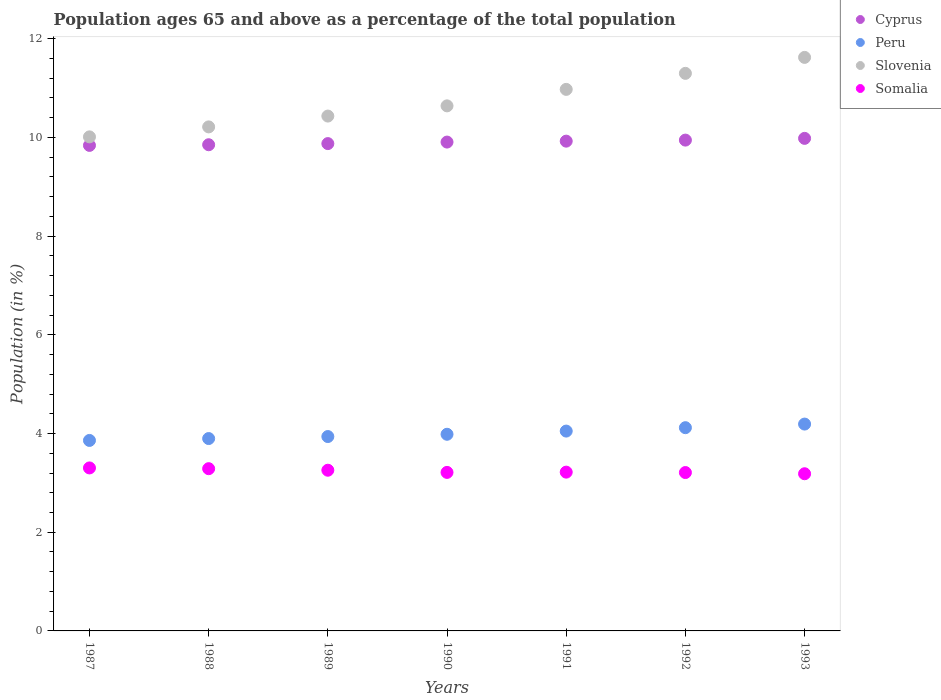Is the number of dotlines equal to the number of legend labels?
Your response must be concise. Yes. What is the percentage of the population ages 65 and above in Peru in 1989?
Keep it short and to the point. 3.94. Across all years, what is the maximum percentage of the population ages 65 and above in Cyprus?
Provide a short and direct response. 9.98. Across all years, what is the minimum percentage of the population ages 65 and above in Cyprus?
Provide a short and direct response. 9.84. In which year was the percentage of the population ages 65 and above in Somalia minimum?
Offer a very short reply. 1993. What is the total percentage of the population ages 65 and above in Cyprus in the graph?
Provide a short and direct response. 69.33. What is the difference between the percentage of the population ages 65 and above in Slovenia in 1989 and that in 1991?
Offer a very short reply. -0.54. What is the difference between the percentage of the population ages 65 and above in Cyprus in 1992 and the percentage of the population ages 65 and above in Somalia in 1989?
Your response must be concise. 6.69. What is the average percentage of the population ages 65 and above in Cyprus per year?
Keep it short and to the point. 9.9. In the year 1990, what is the difference between the percentage of the population ages 65 and above in Peru and percentage of the population ages 65 and above in Cyprus?
Your answer should be compact. -5.92. In how many years, is the percentage of the population ages 65 and above in Slovenia greater than 9.6?
Your answer should be very brief. 7. What is the ratio of the percentage of the population ages 65 and above in Slovenia in 1987 to that in 1988?
Make the answer very short. 0.98. Is the percentage of the population ages 65 and above in Somalia in 1989 less than that in 1993?
Provide a succinct answer. No. What is the difference between the highest and the second highest percentage of the population ages 65 and above in Slovenia?
Your answer should be very brief. 0.32. What is the difference between the highest and the lowest percentage of the population ages 65 and above in Somalia?
Offer a very short reply. 0.12. Is the sum of the percentage of the population ages 65 and above in Slovenia in 1990 and 1991 greater than the maximum percentage of the population ages 65 and above in Cyprus across all years?
Keep it short and to the point. Yes. Is it the case that in every year, the sum of the percentage of the population ages 65 and above in Cyprus and percentage of the population ages 65 and above in Somalia  is greater than the sum of percentage of the population ages 65 and above in Peru and percentage of the population ages 65 and above in Slovenia?
Ensure brevity in your answer.  No. Does the percentage of the population ages 65 and above in Somalia monotonically increase over the years?
Keep it short and to the point. No. Is the percentage of the population ages 65 and above in Cyprus strictly greater than the percentage of the population ages 65 and above in Slovenia over the years?
Provide a succinct answer. No. Is the percentage of the population ages 65 and above in Cyprus strictly less than the percentage of the population ages 65 and above in Slovenia over the years?
Offer a terse response. Yes. How many dotlines are there?
Provide a short and direct response. 4. How many years are there in the graph?
Provide a short and direct response. 7. Are the values on the major ticks of Y-axis written in scientific E-notation?
Offer a terse response. No. How many legend labels are there?
Offer a very short reply. 4. How are the legend labels stacked?
Give a very brief answer. Vertical. What is the title of the graph?
Make the answer very short. Population ages 65 and above as a percentage of the total population. Does "Malawi" appear as one of the legend labels in the graph?
Keep it short and to the point. No. What is the label or title of the Y-axis?
Offer a terse response. Population (in %). What is the Population (in %) in Cyprus in 1987?
Give a very brief answer. 9.84. What is the Population (in %) in Peru in 1987?
Provide a succinct answer. 3.86. What is the Population (in %) in Slovenia in 1987?
Offer a very short reply. 10.01. What is the Population (in %) in Somalia in 1987?
Offer a very short reply. 3.3. What is the Population (in %) of Cyprus in 1988?
Offer a very short reply. 9.85. What is the Population (in %) of Peru in 1988?
Ensure brevity in your answer.  3.9. What is the Population (in %) of Slovenia in 1988?
Provide a short and direct response. 10.21. What is the Population (in %) in Somalia in 1988?
Offer a terse response. 3.29. What is the Population (in %) in Cyprus in 1989?
Your response must be concise. 9.88. What is the Population (in %) of Peru in 1989?
Ensure brevity in your answer.  3.94. What is the Population (in %) in Slovenia in 1989?
Offer a terse response. 10.43. What is the Population (in %) in Somalia in 1989?
Provide a succinct answer. 3.26. What is the Population (in %) in Cyprus in 1990?
Give a very brief answer. 9.91. What is the Population (in %) in Peru in 1990?
Offer a very short reply. 3.99. What is the Population (in %) in Slovenia in 1990?
Your answer should be very brief. 10.64. What is the Population (in %) in Somalia in 1990?
Keep it short and to the point. 3.21. What is the Population (in %) in Cyprus in 1991?
Your answer should be very brief. 9.93. What is the Population (in %) of Peru in 1991?
Provide a succinct answer. 4.05. What is the Population (in %) in Slovenia in 1991?
Make the answer very short. 10.97. What is the Population (in %) of Somalia in 1991?
Give a very brief answer. 3.22. What is the Population (in %) of Cyprus in 1992?
Your answer should be very brief. 9.95. What is the Population (in %) of Peru in 1992?
Offer a terse response. 4.12. What is the Population (in %) in Slovenia in 1992?
Your answer should be compact. 11.3. What is the Population (in %) of Somalia in 1992?
Your response must be concise. 3.21. What is the Population (in %) in Cyprus in 1993?
Your answer should be compact. 9.98. What is the Population (in %) of Peru in 1993?
Ensure brevity in your answer.  4.19. What is the Population (in %) of Slovenia in 1993?
Your response must be concise. 11.62. What is the Population (in %) of Somalia in 1993?
Make the answer very short. 3.19. Across all years, what is the maximum Population (in %) in Cyprus?
Offer a terse response. 9.98. Across all years, what is the maximum Population (in %) of Peru?
Ensure brevity in your answer.  4.19. Across all years, what is the maximum Population (in %) in Slovenia?
Your response must be concise. 11.62. Across all years, what is the maximum Population (in %) of Somalia?
Give a very brief answer. 3.3. Across all years, what is the minimum Population (in %) of Cyprus?
Provide a succinct answer. 9.84. Across all years, what is the minimum Population (in %) in Peru?
Offer a very short reply. 3.86. Across all years, what is the minimum Population (in %) in Slovenia?
Offer a terse response. 10.01. Across all years, what is the minimum Population (in %) in Somalia?
Provide a short and direct response. 3.19. What is the total Population (in %) in Cyprus in the graph?
Provide a short and direct response. 69.33. What is the total Population (in %) of Peru in the graph?
Ensure brevity in your answer.  28.04. What is the total Population (in %) in Slovenia in the graph?
Make the answer very short. 75.2. What is the total Population (in %) of Somalia in the graph?
Provide a short and direct response. 22.67. What is the difference between the Population (in %) in Cyprus in 1987 and that in 1988?
Your answer should be compact. -0.01. What is the difference between the Population (in %) in Peru in 1987 and that in 1988?
Provide a short and direct response. -0.04. What is the difference between the Population (in %) of Slovenia in 1987 and that in 1988?
Give a very brief answer. -0.2. What is the difference between the Population (in %) of Somalia in 1987 and that in 1988?
Your answer should be compact. 0.02. What is the difference between the Population (in %) in Cyprus in 1987 and that in 1989?
Your answer should be compact. -0.04. What is the difference between the Population (in %) of Peru in 1987 and that in 1989?
Offer a terse response. -0.08. What is the difference between the Population (in %) in Slovenia in 1987 and that in 1989?
Give a very brief answer. -0.42. What is the difference between the Population (in %) of Somalia in 1987 and that in 1989?
Provide a succinct answer. 0.05. What is the difference between the Population (in %) of Cyprus in 1987 and that in 1990?
Ensure brevity in your answer.  -0.07. What is the difference between the Population (in %) of Peru in 1987 and that in 1990?
Give a very brief answer. -0.12. What is the difference between the Population (in %) in Slovenia in 1987 and that in 1990?
Offer a terse response. -0.63. What is the difference between the Population (in %) of Somalia in 1987 and that in 1990?
Make the answer very short. 0.09. What is the difference between the Population (in %) in Cyprus in 1987 and that in 1991?
Your answer should be very brief. -0.09. What is the difference between the Population (in %) in Peru in 1987 and that in 1991?
Keep it short and to the point. -0.19. What is the difference between the Population (in %) in Slovenia in 1987 and that in 1991?
Ensure brevity in your answer.  -0.96. What is the difference between the Population (in %) of Somalia in 1987 and that in 1991?
Offer a very short reply. 0.09. What is the difference between the Population (in %) in Cyprus in 1987 and that in 1992?
Ensure brevity in your answer.  -0.11. What is the difference between the Population (in %) in Peru in 1987 and that in 1992?
Offer a terse response. -0.26. What is the difference between the Population (in %) of Slovenia in 1987 and that in 1992?
Ensure brevity in your answer.  -1.29. What is the difference between the Population (in %) in Somalia in 1987 and that in 1992?
Keep it short and to the point. 0.09. What is the difference between the Population (in %) in Cyprus in 1987 and that in 1993?
Ensure brevity in your answer.  -0.14. What is the difference between the Population (in %) in Peru in 1987 and that in 1993?
Give a very brief answer. -0.33. What is the difference between the Population (in %) of Slovenia in 1987 and that in 1993?
Give a very brief answer. -1.61. What is the difference between the Population (in %) in Somalia in 1987 and that in 1993?
Your answer should be compact. 0.12. What is the difference between the Population (in %) in Cyprus in 1988 and that in 1989?
Provide a succinct answer. -0.02. What is the difference between the Population (in %) of Peru in 1988 and that in 1989?
Make the answer very short. -0.04. What is the difference between the Population (in %) in Slovenia in 1988 and that in 1989?
Offer a terse response. -0.22. What is the difference between the Population (in %) in Somalia in 1988 and that in 1989?
Your answer should be very brief. 0.03. What is the difference between the Population (in %) of Cyprus in 1988 and that in 1990?
Keep it short and to the point. -0.05. What is the difference between the Population (in %) in Peru in 1988 and that in 1990?
Make the answer very short. -0.09. What is the difference between the Population (in %) of Slovenia in 1988 and that in 1990?
Keep it short and to the point. -0.43. What is the difference between the Population (in %) of Somalia in 1988 and that in 1990?
Offer a terse response. 0.08. What is the difference between the Population (in %) in Cyprus in 1988 and that in 1991?
Your answer should be compact. -0.07. What is the difference between the Population (in %) of Peru in 1988 and that in 1991?
Provide a short and direct response. -0.15. What is the difference between the Population (in %) of Slovenia in 1988 and that in 1991?
Make the answer very short. -0.76. What is the difference between the Population (in %) of Somalia in 1988 and that in 1991?
Keep it short and to the point. 0.07. What is the difference between the Population (in %) of Cyprus in 1988 and that in 1992?
Keep it short and to the point. -0.09. What is the difference between the Population (in %) of Peru in 1988 and that in 1992?
Your answer should be compact. -0.22. What is the difference between the Population (in %) of Slovenia in 1988 and that in 1992?
Keep it short and to the point. -1.09. What is the difference between the Population (in %) of Somalia in 1988 and that in 1992?
Your answer should be compact. 0.08. What is the difference between the Population (in %) in Cyprus in 1988 and that in 1993?
Your response must be concise. -0.13. What is the difference between the Population (in %) of Peru in 1988 and that in 1993?
Give a very brief answer. -0.29. What is the difference between the Population (in %) of Slovenia in 1988 and that in 1993?
Provide a short and direct response. -1.41. What is the difference between the Population (in %) in Somalia in 1988 and that in 1993?
Your answer should be very brief. 0.1. What is the difference between the Population (in %) of Cyprus in 1989 and that in 1990?
Keep it short and to the point. -0.03. What is the difference between the Population (in %) of Peru in 1989 and that in 1990?
Your response must be concise. -0.05. What is the difference between the Population (in %) of Slovenia in 1989 and that in 1990?
Ensure brevity in your answer.  -0.21. What is the difference between the Population (in %) in Somalia in 1989 and that in 1990?
Provide a succinct answer. 0.04. What is the difference between the Population (in %) in Cyprus in 1989 and that in 1991?
Give a very brief answer. -0.05. What is the difference between the Population (in %) of Peru in 1989 and that in 1991?
Make the answer very short. -0.11. What is the difference between the Population (in %) of Slovenia in 1989 and that in 1991?
Make the answer very short. -0.54. What is the difference between the Population (in %) in Somalia in 1989 and that in 1991?
Your response must be concise. 0.04. What is the difference between the Population (in %) of Cyprus in 1989 and that in 1992?
Provide a short and direct response. -0.07. What is the difference between the Population (in %) of Peru in 1989 and that in 1992?
Keep it short and to the point. -0.18. What is the difference between the Population (in %) of Slovenia in 1989 and that in 1992?
Keep it short and to the point. -0.87. What is the difference between the Population (in %) in Somalia in 1989 and that in 1992?
Your response must be concise. 0.05. What is the difference between the Population (in %) of Cyprus in 1989 and that in 1993?
Keep it short and to the point. -0.11. What is the difference between the Population (in %) of Peru in 1989 and that in 1993?
Your response must be concise. -0.25. What is the difference between the Population (in %) of Slovenia in 1989 and that in 1993?
Ensure brevity in your answer.  -1.19. What is the difference between the Population (in %) of Somalia in 1989 and that in 1993?
Provide a short and direct response. 0.07. What is the difference between the Population (in %) of Cyprus in 1990 and that in 1991?
Offer a very short reply. -0.02. What is the difference between the Population (in %) of Peru in 1990 and that in 1991?
Provide a succinct answer. -0.06. What is the difference between the Population (in %) in Slovenia in 1990 and that in 1991?
Your answer should be compact. -0.33. What is the difference between the Population (in %) in Somalia in 1990 and that in 1991?
Provide a short and direct response. -0.01. What is the difference between the Population (in %) in Cyprus in 1990 and that in 1992?
Your answer should be very brief. -0.04. What is the difference between the Population (in %) of Peru in 1990 and that in 1992?
Offer a very short reply. -0.13. What is the difference between the Population (in %) in Slovenia in 1990 and that in 1992?
Give a very brief answer. -0.66. What is the difference between the Population (in %) in Somalia in 1990 and that in 1992?
Keep it short and to the point. 0. What is the difference between the Population (in %) of Cyprus in 1990 and that in 1993?
Offer a terse response. -0.08. What is the difference between the Population (in %) in Peru in 1990 and that in 1993?
Provide a short and direct response. -0.21. What is the difference between the Population (in %) in Slovenia in 1990 and that in 1993?
Offer a very short reply. -0.98. What is the difference between the Population (in %) in Somalia in 1990 and that in 1993?
Provide a succinct answer. 0.03. What is the difference between the Population (in %) in Cyprus in 1991 and that in 1992?
Your answer should be compact. -0.02. What is the difference between the Population (in %) in Peru in 1991 and that in 1992?
Give a very brief answer. -0.07. What is the difference between the Population (in %) of Slovenia in 1991 and that in 1992?
Offer a very short reply. -0.32. What is the difference between the Population (in %) of Somalia in 1991 and that in 1992?
Make the answer very short. 0.01. What is the difference between the Population (in %) of Cyprus in 1991 and that in 1993?
Your response must be concise. -0.06. What is the difference between the Population (in %) in Peru in 1991 and that in 1993?
Your answer should be very brief. -0.14. What is the difference between the Population (in %) in Slovenia in 1991 and that in 1993?
Provide a succinct answer. -0.65. What is the difference between the Population (in %) in Somalia in 1991 and that in 1993?
Ensure brevity in your answer.  0.03. What is the difference between the Population (in %) in Cyprus in 1992 and that in 1993?
Offer a very short reply. -0.04. What is the difference between the Population (in %) in Peru in 1992 and that in 1993?
Give a very brief answer. -0.07. What is the difference between the Population (in %) in Slovenia in 1992 and that in 1993?
Your answer should be very brief. -0.32. What is the difference between the Population (in %) of Somalia in 1992 and that in 1993?
Ensure brevity in your answer.  0.02. What is the difference between the Population (in %) in Cyprus in 1987 and the Population (in %) in Peru in 1988?
Provide a short and direct response. 5.94. What is the difference between the Population (in %) of Cyprus in 1987 and the Population (in %) of Slovenia in 1988?
Keep it short and to the point. -0.37. What is the difference between the Population (in %) in Cyprus in 1987 and the Population (in %) in Somalia in 1988?
Your answer should be very brief. 6.55. What is the difference between the Population (in %) of Peru in 1987 and the Population (in %) of Slovenia in 1988?
Offer a terse response. -6.35. What is the difference between the Population (in %) in Peru in 1987 and the Population (in %) in Somalia in 1988?
Provide a succinct answer. 0.57. What is the difference between the Population (in %) of Slovenia in 1987 and the Population (in %) of Somalia in 1988?
Ensure brevity in your answer.  6.72. What is the difference between the Population (in %) of Cyprus in 1987 and the Population (in %) of Peru in 1989?
Your response must be concise. 5.9. What is the difference between the Population (in %) in Cyprus in 1987 and the Population (in %) in Slovenia in 1989?
Offer a terse response. -0.59. What is the difference between the Population (in %) of Cyprus in 1987 and the Population (in %) of Somalia in 1989?
Provide a short and direct response. 6.58. What is the difference between the Population (in %) in Peru in 1987 and the Population (in %) in Slovenia in 1989?
Your answer should be very brief. -6.57. What is the difference between the Population (in %) of Peru in 1987 and the Population (in %) of Somalia in 1989?
Offer a terse response. 0.6. What is the difference between the Population (in %) in Slovenia in 1987 and the Population (in %) in Somalia in 1989?
Ensure brevity in your answer.  6.76. What is the difference between the Population (in %) of Cyprus in 1987 and the Population (in %) of Peru in 1990?
Provide a succinct answer. 5.85. What is the difference between the Population (in %) in Cyprus in 1987 and the Population (in %) in Slovenia in 1990?
Your answer should be compact. -0.8. What is the difference between the Population (in %) in Cyprus in 1987 and the Population (in %) in Somalia in 1990?
Your response must be concise. 6.63. What is the difference between the Population (in %) of Peru in 1987 and the Population (in %) of Slovenia in 1990?
Your answer should be compact. -6.78. What is the difference between the Population (in %) in Peru in 1987 and the Population (in %) in Somalia in 1990?
Ensure brevity in your answer.  0.65. What is the difference between the Population (in %) in Slovenia in 1987 and the Population (in %) in Somalia in 1990?
Ensure brevity in your answer.  6.8. What is the difference between the Population (in %) in Cyprus in 1987 and the Population (in %) in Peru in 1991?
Offer a terse response. 5.79. What is the difference between the Population (in %) in Cyprus in 1987 and the Population (in %) in Slovenia in 1991?
Ensure brevity in your answer.  -1.14. What is the difference between the Population (in %) in Cyprus in 1987 and the Population (in %) in Somalia in 1991?
Ensure brevity in your answer.  6.62. What is the difference between the Population (in %) in Peru in 1987 and the Population (in %) in Slovenia in 1991?
Give a very brief answer. -7.11. What is the difference between the Population (in %) of Peru in 1987 and the Population (in %) of Somalia in 1991?
Your response must be concise. 0.64. What is the difference between the Population (in %) of Slovenia in 1987 and the Population (in %) of Somalia in 1991?
Your response must be concise. 6.79. What is the difference between the Population (in %) in Cyprus in 1987 and the Population (in %) in Peru in 1992?
Ensure brevity in your answer.  5.72. What is the difference between the Population (in %) of Cyprus in 1987 and the Population (in %) of Slovenia in 1992?
Offer a very short reply. -1.46. What is the difference between the Population (in %) in Cyprus in 1987 and the Population (in %) in Somalia in 1992?
Keep it short and to the point. 6.63. What is the difference between the Population (in %) of Peru in 1987 and the Population (in %) of Slovenia in 1992?
Provide a succinct answer. -7.44. What is the difference between the Population (in %) in Peru in 1987 and the Population (in %) in Somalia in 1992?
Provide a succinct answer. 0.65. What is the difference between the Population (in %) of Slovenia in 1987 and the Population (in %) of Somalia in 1992?
Offer a terse response. 6.8. What is the difference between the Population (in %) of Cyprus in 1987 and the Population (in %) of Peru in 1993?
Ensure brevity in your answer.  5.65. What is the difference between the Population (in %) of Cyprus in 1987 and the Population (in %) of Slovenia in 1993?
Provide a short and direct response. -1.78. What is the difference between the Population (in %) of Cyprus in 1987 and the Population (in %) of Somalia in 1993?
Give a very brief answer. 6.65. What is the difference between the Population (in %) in Peru in 1987 and the Population (in %) in Slovenia in 1993?
Your answer should be compact. -7.76. What is the difference between the Population (in %) of Peru in 1987 and the Population (in %) of Somalia in 1993?
Give a very brief answer. 0.68. What is the difference between the Population (in %) in Slovenia in 1987 and the Population (in %) in Somalia in 1993?
Make the answer very short. 6.83. What is the difference between the Population (in %) in Cyprus in 1988 and the Population (in %) in Peru in 1989?
Keep it short and to the point. 5.91. What is the difference between the Population (in %) in Cyprus in 1988 and the Population (in %) in Slovenia in 1989?
Provide a short and direct response. -0.58. What is the difference between the Population (in %) of Cyprus in 1988 and the Population (in %) of Somalia in 1989?
Your answer should be compact. 6.6. What is the difference between the Population (in %) in Peru in 1988 and the Population (in %) in Slovenia in 1989?
Offer a very short reply. -6.54. What is the difference between the Population (in %) in Peru in 1988 and the Population (in %) in Somalia in 1989?
Give a very brief answer. 0.64. What is the difference between the Population (in %) of Slovenia in 1988 and the Population (in %) of Somalia in 1989?
Your answer should be compact. 6.96. What is the difference between the Population (in %) of Cyprus in 1988 and the Population (in %) of Peru in 1990?
Keep it short and to the point. 5.87. What is the difference between the Population (in %) in Cyprus in 1988 and the Population (in %) in Slovenia in 1990?
Provide a succinct answer. -0.79. What is the difference between the Population (in %) of Cyprus in 1988 and the Population (in %) of Somalia in 1990?
Ensure brevity in your answer.  6.64. What is the difference between the Population (in %) of Peru in 1988 and the Population (in %) of Slovenia in 1990?
Keep it short and to the point. -6.74. What is the difference between the Population (in %) in Peru in 1988 and the Population (in %) in Somalia in 1990?
Keep it short and to the point. 0.69. What is the difference between the Population (in %) in Slovenia in 1988 and the Population (in %) in Somalia in 1990?
Offer a terse response. 7. What is the difference between the Population (in %) in Cyprus in 1988 and the Population (in %) in Peru in 1991?
Provide a succinct answer. 5.8. What is the difference between the Population (in %) in Cyprus in 1988 and the Population (in %) in Slovenia in 1991?
Keep it short and to the point. -1.12. What is the difference between the Population (in %) in Cyprus in 1988 and the Population (in %) in Somalia in 1991?
Offer a terse response. 6.63. What is the difference between the Population (in %) in Peru in 1988 and the Population (in %) in Slovenia in 1991?
Provide a short and direct response. -7.08. What is the difference between the Population (in %) of Peru in 1988 and the Population (in %) of Somalia in 1991?
Make the answer very short. 0.68. What is the difference between the Population (in %) in Slovenia in 1988 and the Population (in %) in Somalia in 1991?
Offer a very short reply. 7. What is the difference between the Population (in %) of Cyprus in 1988 and the Population (in %) of Peru in 1992?
Ensure brevity in your answer.  5.73. What is the difference between the Population (in %) in Cyprus in 1988 and the Population (in %) in Slovenia in 1992?
Provide a short and direct response. -1.45. What is the difference between the Population (in %) in Cyprus in 1988 and the Population (in %) in Somalia in 1992?
Ensure brevity in your answer.  6.64. What is the difference between the Population (in %) in Peru in 1988 and the Population (in %) in Slovenia in 1992?
Your answer should be very brief. -7.4. What is the difference between the Population (in %) in Peru in 1988 and the Population (in %) in Somalia in 1992?
Offer a very short reply. 0.69. What is the difference between the Population (in %) of Slovenia in 1988 and the Population (in %) of Somalia in 1992?
Keep it short and to the point. 7. What is the difference between the Population (in %) of Cyprus in 1988 and the Population (in %) of Peru in 1993?
Make the answer very short. 5.66. What is the difference between the Population (in %) in Cyprus in 1988 and the Population (in %) in Slovenia in 1993?
Your response must be concise. -1.77. What is the difference between the Population (in %) of Cyprus in 1988 and the Population (in %) of Somalia in 1993?
Your answer should be compact. 6.67. What is the difference between the Population (in %) in Peru in 1988 and the Population (in %) in Slovenia in 1993?
Provide a short and direct response. -7.72. What is the difference between the Population (in %) in Peru in 1988 and the Population (in %) in Somalia in 1993?
Offer a very short reply. 0.71. What is the difference between the Population (in %) in Slovenia in 1988 and the Population (in %) in Somalia in 1993?
Your answer should be very brief. 7.03. What is the difference between the Population (in %) of Cyprus in 1989 and the Population (in %) of Peru in 1990?
Keep it short and to the point. 5.89. What is the difference between the Population (in %) in Cyprus in 1989 and the Population (in %) in Slovenia in 1990?
Make the answer very short. -0.76. What is the difference between the Population (in %) in Cyprus in 1989 and the Population (in %) in Somalia in 1990?
Give a very brief answer. 6.66. What is the difference between the Population (in %) of Peru in 1989 and the Population (in %) of Slovenia in 1990?
Keep it short and to the point. -6.7. What is the difference between the Population (in %) in Peru in 1989 and the Population (in %) in Somalia in 1990?
Offer a terse response. 0.73. What is the difference between the Population (in %) of Slovenia in 1989 and the Population (in %) of Somalia in 1990?
Your response must be concise. 7.22. What is the difference between the Population (in %) of Cyprus in 1989 and the Population (in %) of Peru in 1991?
Your answer should be very brief. 5.83. What is the difference between the Population (in %) of Cyprus in 1989 and the Population (in %) of Slovenia in 1991?
Your answer should be very brief. -1.1. What is the difference between the Population (in %) of Cyprus in 1989 and the Population (in %) of Somalia in 1991?
Offer a very short reply. 6.66. What is the difference between the Population (in %) of Peru in 1989 and the Population (in %) of Slovenia in 1991?
Your answer should be compact. -7.04. What is the difference between the Population (in %) of Peru in 1989 and the Population (in %) of Somalia in 1991?
Provide a succinct answer. 0.72. What is the difference between the Population (in %) in Slovenia in 1989 and the Population (in %) in Somalia in 1991?
Your answer should be very brief. 7.22. What is the difference between the Population (in %) of Cyprus in 1989 and the Population (in %) of Peru in 1992?
Your answer should be compact. 5.76. What is the difference between the Population (in %) of Cyprus in 1989 and the Population (in %) of Slovenia in 1992?
Make the answer very short. -1.42. What is the difference between the Population (in %) of Cyprus in 1989 and the Population (in %) of Somalia in 1992?
Your response must be concise. 6.67. What is the difference between the Population (in %) in Peru in 1989 and the Population (in %) in Slovenia in 1992?
Offer a terse response. -7.36. What is the difference between the Population (in %) of Peru in 1989 and the Population (in %) of Somalia in 1992?
Provide a short and direct response. 0.73. What is the difference between the Population (in %) in Slovenia in 1989 and the Population (in %) in Somalia in 1992?
Ensure brevity in your answer.  7.22. What is the difference between the Population (in %) in Cyprus in 1989 and the Population (in %) in Peru in 1993?
Keep it short and to the point. 5.68. What is the difference between the Population (in %) in Cyprus in 1989 and the Population (in %) in Slovenia in 1993?
Provide a short and direct response. -1.75. What is the difference between the Population (in %) in Cyprus in 1989 and the Population (in %) in Somalia in 1993?
Your answer should be very brief. 6.69. What is the difference between the Population (in %) in Peru in 1989 and the Population (in %) in Slovenia in 1993?
Make the answer very short. -7.68. What is the difference between the Population (in %) of Peru in 1989 and the Population (in %) of Somalia in 1993?
Your answer should be compact. 0.75. What is the difference between the Population (in %) of Slovenia in 1989 and the Population (in %) of Somalia in 1993?
Your answer should be very brief. 7.25. What is the difference between the Population (in %) of Cyprus in 1990 and the Population (in %) of Peru in 1991?
Offer a terse response. 5.86. What is the difference between the Population (in %) of Cyprus in 1990 and the Population (in %) of Slovenia in 1991?
Your answer should be very brief. -1.07. What is the difference between the Population (in %) of Cyprus in 1990 and the Population (in %) of Somalia in 1991?
Provide a short and direct response. 6.69. What is the difference between the Population (in %) in Peru in 1990 and the Population (in %) in Slovenia in 1991?
Offer a very short reply. -6.99. What is the difference between the Population (in %) of Peru in 1990 and the Population (in %) of Somalia in 1991?
Provide a short and direct response. 0.77. What is the difference between the Population (in %) of Slovenia in 1990 and the Population (in %) of Somalia in 1991?
Provide a short and direct response. 7.42. What is the difference between the Population (in %) of Cyprus in 1990 and the Population (in %) of Peru in 1992?
Keep it short and to the point. 5.79. What is the difference between the Population (in %) of Cyprus in 1990 and the Population (in %) of Slovenia in 1992?
Your response must be concise. -1.39. What is the difference between the Population (in %) of Cyprus in 1990 and the Population (in %) of Somalia in 1992?
Your answer should be very brief. 6.7. What is the difference between the Population (in %) of Peru in 1990 and the Population (in %) of Slovenia in 1992?
Provide a short and direct response. -7.31. What is the difference between the Population (in %) in Peru in 1990 and the Population (in %) in Somalia in 1992?
Your response must be concise. 0.78. What is the difference between the Population (in %) of Slovenia in 1990 and the Population (in %) of Somalia in 1992?
Offer a terse response. 7.43. What is the difference between the Population (in %) in Cyprus in 1990 and the Population (in %) in Peru in 1993?
Your answer should be compact. 5.71. What is the difference between the Population (in %) of Cyprus in 1990 and the Population (in %) of Slovenia in 1993?
Offer a very short reply. -1.72. What is the difference between the Population (in %) in Cyprus in 1990 and the Population (in %) in Somalia in 1993?
Your response must be concise. 6.72. What is the difference between the Population (in %) of Peru in 1990 and the Population (in %) of Slovenia in 1993?
Your answer should be compact. -7.64. What is the difference between the Population (in %) of Peru in 1990 and the Population (in %) of Somalia in 1993?
Offer a terse response. 0.8. What is the difference between the Population (in %) of Slovenia in 1990 and the Population (in %) of Somalia in 1993?
Your response must be concise. 7.46. What is the difference between the Population (in %) in Cyprus in 1991 and the Population (in %) in Peru in 1992?
Provide a short and direct response. 5.81. What is the difference between the Population (in %) of Cyprus in 1991 and the Population (in %) of Slovenia in 1992?
Provide a succinct answer. -1.37. What is the difference between the Population (in %) in Cyprus in 1991 and the Population (in %) in Somalia in 1992?
Your answer should be very brief. 6.72. What is the difference between the Population (in %) of Peru in 1991 and the Population (in %) of Slovenia in 1992?
Make the answer very short. -7.25. What is the difference between the Population (in %) of Peru in 1991 and the Population (in %) of Somalia in 1992?
Offer a terse response. 0.84. What is the difference between the Population (in %) in Slovenia in 1991 and the Population (in %) in Somalia in 1992?
Offer a very short reply. 7.76. What is the difference between the Population (in %) of Cyprus in 1991 and the Population (in %) of Peru in 1993?
Give a very brief answer. 5.73. What is the difference between the Population (in %) in Cyprus in 1991 and the Population (in %) in Slovenia in 1993?
Keep it short and to the point. -1.7. What is the difference between the Population (in %) of Cyprus in 1991 and the Population (in %) of Somalia in 1993?
Ensure brevity in your answer.  6.74. What is the difference between the Population (in %) in Peru in 1991 and the Population (in %) in Slovenia in 1993?
Your answer should be compact. -7.57. What is the difference between the Population (in %) of Peru in 1991 and the Population (in %) of Somalia in 1993?
Provide a short and direct response. 0.86. What is the difference between the Population (in %) of Slovenia in 1991 and the Population (in %) of Somalia in 1993?
Give a very brief answer. 7.79. What is the difference between the Population (in %) in Cyprus in 1992 and the Population (in %) in Peru in 1993?
Provide a short and direct response. 5.75. What is the difference between the Population (in %) of Cyprus in 1992 and the Population (in %) of Slovenia in 1993?
Provide a short and direct response. -1.68. What is the difference between the Population (in %) of Cyprus in 1992 and the Population (in %) of Somalia in 1993?
Provide a succinct answer. 6.76. What is the difference between the Population (in %) of Peru in 1992 and the Population (in %) of Slovenia in 1993?
Your answer should be very brief. -7.5. What is the difference between the Population (in %) in Peru in 1992 and the Population (in %) in Somalia in 1993?
Provide a short and direct response. 0.93. What is the difference between the Population (in %) of Slovenia in 1992 and the Population (in %) of Somalia in 1993?
Your response must be concise. 8.11. What is the average Population (in %) in Cyprus per year?
Keep it short and to the point. 9.9. What is the average Population (in %) in Peru per year?
Make the answer very short. 4.01. What is the average Population (in %) of Slovenia per year?
Provide a succinct answer. 10.74. What is the average Population (in %) in Somalia per year?
Offer a very short reply. 3.24. In the year 1987, what is the difference between the Population (in %) of Cyprus and Population (in %) of Peru?
Your response must be concise. 5.98. In the year 1987, what is the difference between the Population (in %) in Cyprus and Population (in %) in Slovenia?
Give a very brief answer. -0.17. In the year 1987, what is the difference between the Population (in %) of Cyprus and Population (in %) of Somalia?
Keep it short and to the point. 6.54. In the year 1987, what is the difference between the Population (in %) in Peru and Population (in %) in Slovenia?
Give a very brief answer. -6.15. In the year 1987, what is the difference between the Population (in %) of Peru and Population (in %) of Somalia?
Your response must be concise. 0.56. In the year 1987, what is the difference between the Population (in %) of Slovenia and Population (in %) of Somalia?
Provide a short and direct response. 6.71. In the year 1988, what is the difference between the Population (in %) in Cyprus and Population (in %) in Peru?
Your response must be concise. 5.95. In the year 1988, what is the difference between the Population (in %) in Cyprus and Population (in %) in Slovenia?
Your answer should be compact. -0.36. In the year 1988, what is the difference between the Population (in %) in Cyprus and Population (in %) in Somalia?
Provide a short and direct response. 6.56. In the year 1988, what is the difference between the Population (in %) in Peru and Population (in %) in Slovenia?
Provide a succinct answer. -6.32. In the year 1988, what is the difference between the Population (in %) of Peru and Population (in %) of Somalia?
Offer a very short reply. 0.61. In the year 1988, what is the difference between the Population (in %) in Slovenia and Population (in %) in Somalia?
Your response must be concise. 6.93. In the year 1989, what is the difference between the Population (in %) of Cyprus and Population (in %) of Peru?
Keep it short and to the point. 5.94. In the year 1989, what is the difference between the Population (in %) in Cyprus and Population (in %) in Slovenia?
Offer a very short reply. -0.56. In the year 1989, what is the difference between the Population (in %) in Cyprus and Population (in %) in Somalia?
Offer a terse response. 6.62. In the year 1989, what is the difference between the Population (in %) in Peru and Population (in %) in Slovenia?
Give a very brief answer. -6.49. In the year 1989, what is the difference between the Population (in %) in Peru and Population (in %) in Somalia?
Provide a succinct answer. 0.68. In the year 1989, what is the difference between the Population (in %) in Slovenia and Population (in %) in Somalia?
Make the answer very short. 7.18. In the year 1990, what is the difference between the Population (in %) in Cyprus and Population (in %) in Peru?
Provide a succinct answer. 5.92. In the year 1990, what is the difference between the Population (in %) in Cyprus and Population (in %) in Slovenia?
Your response must be concise. -0.73. In the year 1990, what is the difference between the Population (in %) in Cyprus and Population (in %) in Somalia?
Ensure brevity in your answer.  6.69. In the year 1990, what is the difference between the Population (in %) in Peru and Population (in %) in Slovenia?
Keep it short and to the point. -6.66. In the year 1990, what is the difference between the Population (in %) in Peru and Population (in %) in Somalia?
Provide a short and direct response. 0.77. In the year 1990, what is the difference between the Population (in %) of Slovenia and Population (in %) of Somalia?
Ensure brevity in your answer.  7.43. In the year 1991, what is the difference between the Population (in %) in Cyprus and Population (in %) in Peru?
Make the answer very short. 5.88. In the year 1991, what is the difference between the Population (in %) of Cyprus and Population (in %) of Slovenia?
Keep it short and to the point. -1.05. In the year 1991, what is the difference between the Population (in %) in Cyprus and Population (in %) in Somalia?
Keep it short and to the point. 6.71. In the year 1991, what is the difference between the Population (in %) in Peru and Population (in %) in Slovenia?
Your answer should be compact. -6.92. In the year 1991, what is the difference between the Population (in %) of Peru and Population (in %) of Somalia?
Ensure brevity in your answer.  0.83. In the year 1991, what is the difference between the Population (in %) of Slovenia and Population (in %) of Somalia?
Your answer should be compact. 7.76. In the year 1992, what is the difference between the Population (in %) of Cyprus and Population (in %) of Peru?
Offer a very short reply. 5.83. In the year 1992, what is the difference between the Population (in %) in Cyprus and Population (in %) in Slovenia?
Ensure brevity in your answer.  -1.35. In the year 1992, what is the difference between the Population (in %) in Cyprus and Population (in %) in Somalia?
Offer a very short reply. 6.74. In the year 1992, what is the difference between the Population (in %) of Peru and Population (in %) of Slovenia?
Your answer should be very brief. -7.18. In the year 1992, what is the difference between the Population (in %) in Peru and Population (in %) in Somalia?
Offer a terse response. 0.91. In the year 1992, what is the difference between the Population (in %) of Slovenia and Population (in %) of Somalia?
Provide a short and direct response. 8.09. In the year 1993, what is the difference between the Population (in %) in Cyprus and Population (in %) in Peru?
Provide a succinct answer. 5.79. In the year 1993, what is the difference between the Population (in %) of Cyprus and Population (in %) of Slovenia?
Ensure brevity in your answer.  -1.64. In the year 1993, what is the difference between the Population (in %) of Cyprus and Population (in %) of Somalia?
Your response must be concise. 6.8. In the year 1993, what is the difference between the Population (in %) of Peru and Population (in %) of Slovenia?
Give a very brief answer. -7.43. In the year 1993, what is the difference between the Population (in %) of Peru and Population (in %) of Somalia?
Offer a very short reply. 1.01. In the year 1993, what is the difference between the Population (in %) of Slovenia and Population (in %) of Somalia?
Give a very brief answer. 8.44. What is the ratio of the Population (in %) of Peru in 1987 to that in 1988?
Offer a terse response. 0.99. What is the ratio of the Population (in %) of Slovenia in 1987 to that in 1988?
Give a very brief answer. 0.98. What is the ratio of the Population (in %) of Somalia in 1987 to that in 1988?
Provide a short and direct response. 1. What is the ratio of the Population (in %) in Peru in 1987 to that in 1989?
Your answer should be compact. 0.98. What is the ratio of the Population (in %) of Slovenia in 1987 to that in 1989?
Your response must be concise. 0.96. What is the ratio of the Population (in %) of Somalia in 1987 to that in 1989?
Provide a short and direct response. 1.01. What is the ratio of the Population (in %) of Peru in 1987 to that in 1990?
Give a very brief answer. 0.97. What is the ratio of the Population (in %) in Slovenia in 1987 to that in 1990?
Provide a short and direct response. 0.94. What is the ratio of the Population (in %) of Somalia in 1987 to that in 1990?
Provide a short and direct response. 1.03. What is the ratio of the Population (in %) in Cyprus in 1987 to that in 1991?
Offer a terse response. 0.99. What is the ratio of the Population (in %) of Peru in 1987 to that in 1991?
Your answer should be very brief. 0.95. What is the ratio of the Population (in %) in Slovenia in 1987 to that in 1991?
Make the answer very short. 0.91. What is the ratio of the Population (in %) of Somalia in 1987 to that in 1991?
Offer a terse response. 1.03. What is the ratio of the Population (in %) of Cyprus in 1987 to that in 1992?
Offer a terse response. 0.99. What is the ratio of the Population (in %) of Peru in 1987 to that in 1992?
Your answer should be compact. 0.94. What is the ratio of the Population (in %) in Slovenia in 1987 to that in 1992?
Ensure brevity in your answer.  0.89. What is the ratio of the Population (in %) in Somalia in 1987 to that in 1992?
Offer a very short reply. 1.03. What is the ratio of the Population (in %) of Cyprus in 1987 to that in 1993?
Offer a terse response. 0.99. What is the ratio of the Population (in %) of Peru in 1987 to that in 1993?
Your answer should be compact. 0.92. What is the ratio of the Population (in %) of Slovenia in 1987 to that in 1993?
Provide a short and direct response. 0.86. What is the ratio of the Population (in %) of Cyprus in 1988 to that in 1989?
Make the answer very short. 1. What is the ratio of the Population (in %) in Peru in 1988 to that in 1989?
Provide a succinct answer. 0.99. What is the ratio of the Population (in %) in Somalia in 1988 to that in 1989?
Provide a succinct answer. 1.01. What is the ratio of the Population (in %) of Cyprus in 1988 to that in 1990?
Offer a terse response. 0.99. What is the ratio of the Population (in %) in Peru in 1988 to that in 1990?
Provide a short and direct response. 0.98. What is the ratio of the Population (in %) in Slovenia in 1988 to that in 1990?
Your answer should be very brief. 0.96. What is the ratio of the Population (in %) of Somalia in 1988 to that in 1990?
Offer a very short reply. 1.02. What is the ratio of the Population (in %) of Cyprus in 1988 to that in 1991?
Provide a short and direct response. 0.99. What is the ratio of the Population (in %) in Peru in 1988 to that in 1991?
Your response must be concise. 0.96. What is the ratio of the Population (in %) of Slovenia in 1988 to that in 1991?
Offer a very short reply. 0.93. What is the ratio of the Population (in %) of Somalia in 1988 to that in 1991?
Keep it short and to the point. 1.02. What is the ratio of the Population (in %) in Cyprus in 1988 to that in 1992?
Your response must be concise. 0.99. What is the ratio of the Population (in %) in Peru in 1988 to that in 1992?
Offer a very short reply. 0.95. What is the ratio of the Population (in %) of Slovenia in 1988 to that in 1992?
Offer a terse response. 0.9. What is the ratio of the Population (in %) of Somalia in 1988 to that in 1992?
Give a very brief answer. 1.02. What is the ratio of the Population (in %) of Cyprus in 1988 to that in 1993?
Your response must be concise. 0.99. What is the ratio of the Population (in %) of Peru in 1988 to that in 1993?
Offer a terse response. 0.93. What is the ratio of the Population (in %) of Slovenia in 1988 to that in 1993?
Your answer should be very brief. 0.88. What is the ratio of the Population (in %) in Somalia in 1988 to that in 1993?
Provide a succinct answer. 1.03. What is the ratio of the Population (in %) in Cyprus in 1989 to that in 1990?
Keep it short and to the point. 1. What is the ratio of the Population (in %) in Peru in 1989 to that in 1990?
Provide a short and direct response. 0.99. What is the ratio of the Population (in %) in Slovenia in 1989 to that in 1990?
Offer a terse response. 0.98. What is the ratio of the Population (in %) in Somalia in 1989 to that in 1990?
Provide a succinct answer. 1.01. What is the ratio of the Population (in %) in Cyprus in 1989 to that in 1991?
Offer a very short reply. 0.99. What is the ratio of the Population (in %) in Peru in 1989 to that in 1991?
Ensure brevity in your answer.  0.97. What is the ratio of the Population (in %) of Slovenia in 1989 to that in 1991?
Keep it short and to the point. 0.95. What is the ratio of the Population (in %) in Cyprus in 1989 to that in 1992?
Make the answer very short. 0.99. What is the ratio of the Population (in %) of Peru in 1989 to that in 1992?
Your response must be concise. 0.96. What is the ratio of the Population (in %) in Slovenia in 1989 to that in 1992?
Offer a terse response. 0.92. What is the ratio of the Population (in %) in Somalia in 1989 to that in 1992?
Your answer should be very brief. 1.01. What is the ratio of the Population (in %) in Cyprus in 1989 to that in 1993?
Offer a terse response. 0.99. What is the ratio of the Population (in %) in Peru in 1989 to that in 1993?
Offer a very short reply. 0.94. What is the ratio of the Population (in %) of Slovenia in 1989 to that in 1993?
Keep it short and to the point. 0.9. What is the ratio of the Population (in %) in Somalia in 1989 to that in 1993?
Provide a short and direct response. 1.02. What is the ratio of the Population (in %) in Cyprus in 1990 to that in 1991?
Make the answer very short. 1. What is the ratio of the Population (in %) in Slovenia in 1990 to that in 1991?
Keep it short and to the point. 0.97. What is the ratio of the Population (in %) of Cyprus in 1990 to that in 1992?
Keep it short and to the point. 1. What is the ratio of the Population (in %) of Peru in 1990 to that in 1992?
Provide a short and direct response. 0.97. What is the ratio of the Population (in %) in Slovenia in 1990 to that in 1992?
Provide a short and direct response. 0.94. What is the ratio of the Population (in %) in Cyprus in 1990 to that in 1993?
Your answer should be compact. 0.99. What is the ratio of the Population (in %) in Peru in 1990 to that in 1993?
Provide a short and direct response. 0.95. What is the ratio of the Population (in %) in Slovenia in 1990 to that in 1993?
Provide a short and direct response. 0.92. What is the ratio of the Population (in %) of Somalia in 1990 to that in 1993?
Your answer should be very brief. 1.01. What is the ratio of the Population (in %) of Peru in 1991 to that in 1992?
Your response must be concise. 0.98. What is the ratio of the Population (in %) of Slovenia in 1991 to that in 1992?
Offer a very short reply. 0.97. What is the ratio of the Population (in %) of Somalia in 1991 to that in 1992?
Keep it short and to the point. 1. What is the ratio of the Population (in %) in Peru in 1991 to that in 1993?
Your answer should be compact. 0.97. What is the ratio of the Population (in %) in Slovenia in 1991 to that in 1993?
Ensure brevity in your answer.  0.94. What is the ratio of the Population (in %) in Somalia in 1991 to that in 1993?
Offer a very short reply. 1.01. What is the ratio of the Population (in %) in Cyprus in 1992 to that in 1993?
Your response must be concise. 1. What is the ratio of the Population (in %) of Peru in 1992 to that in 1993?
Your answer should be compact. 0.98. What is the ratio of the Population (in %) of Slovenia in 1992 to that in 1993?
Provide a succinct answer. 0.97. What is the ratio of the Population (in %) in Somalia in 1992 to that in 1993?
Ensure brevity in your answer.  1.01. What is the difference between the highest and the second highest Population (in %) in Cyprus?
Ensure brevity in your answer.  0.04. What is the difference between the highest and the second highest Population (in %) in Peru?
Offer a terse response. 0.07. What is the difference between the highest and the second highest Population (in %) of Slovenia?
Give a very brief answer. 0.32. What is the difference between the highest and the second highest Population (in %) in Somalia?
Your answer should be compact. 0.02. What is the difference between the highest and the lowest Population (in %) of Cyprus?
Your answer should be compact. 0.14. What is the difference between the highest and the lowest Population (in %) in Peru?
Your answer should be very brief. 0.33. What is the difference between the highest and the lowest Population (in %) of Slovenia?
Offer a terse response. 1.61. What is the difference between the highest and the lowest Population (in %) in Somalia?
Ensure brevity in your answer.  0.12. 